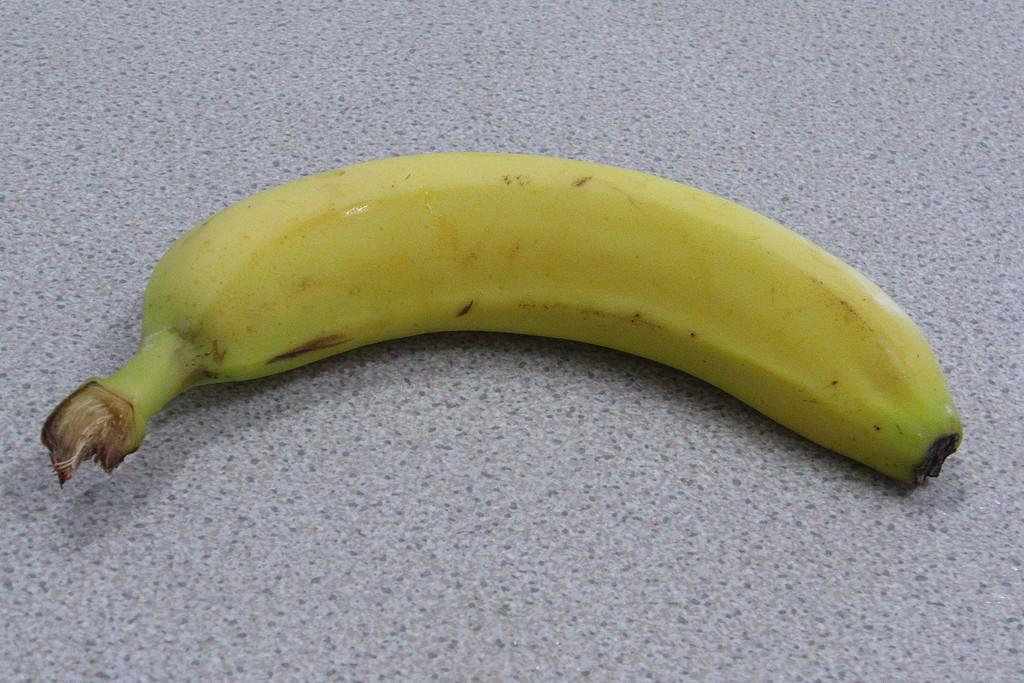What type of fruit is in the image? There is a banana in the image. Where is the banana located in the image? The banana is placed on a surface. What type of humor can be seen in the image? There is no humor present in the image; it simply features a banana on a surface. 